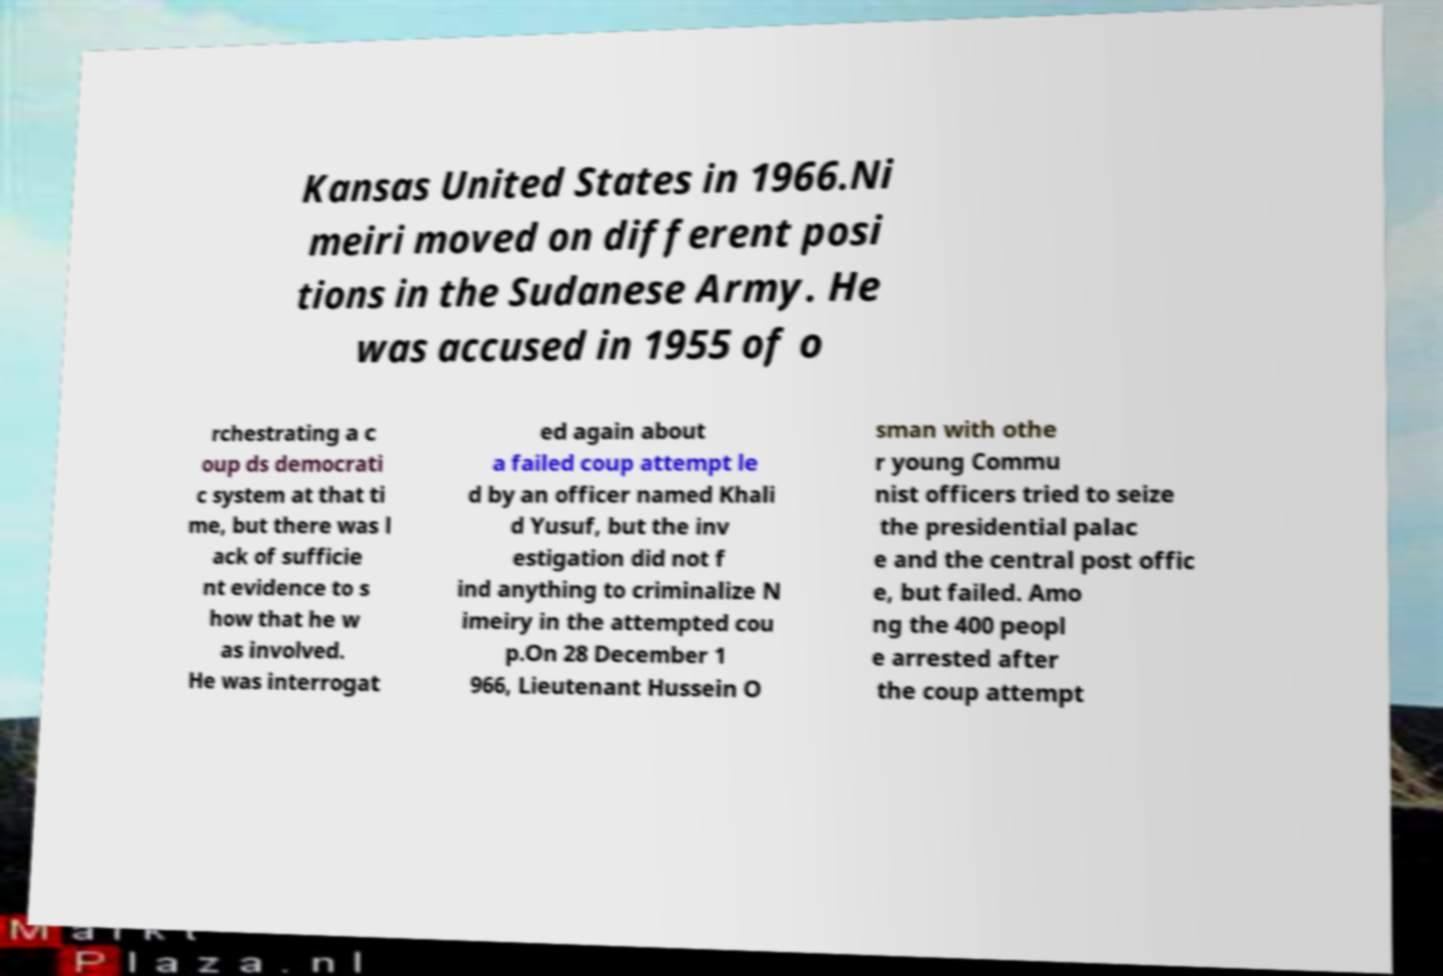Could you assist in decoding the text presented in this image and type it out clearly? Kansas United States in 1966.Ni meiri moved on different posi tions in the Sudanese Army. He was accused in 1955 of o rchestrating a c oup ds democrati c system at that ti me, but there was l ack of sufficie nt evidence to s how that he w as involved. He was interrogat ed again about a failed coup attempt le d by an officer named Khali d Yusuf, but the inv estigation did not f ind anything to criminalize N imeiry in the attempted cou p.On 28 December 1 966, Lieutenant Hussein O sman with othe r young Commu nist officers tried to seize the presidential palac e and the central post offic e, but failed. Amo ng the 400 peopl e arrested after the coup attempt 